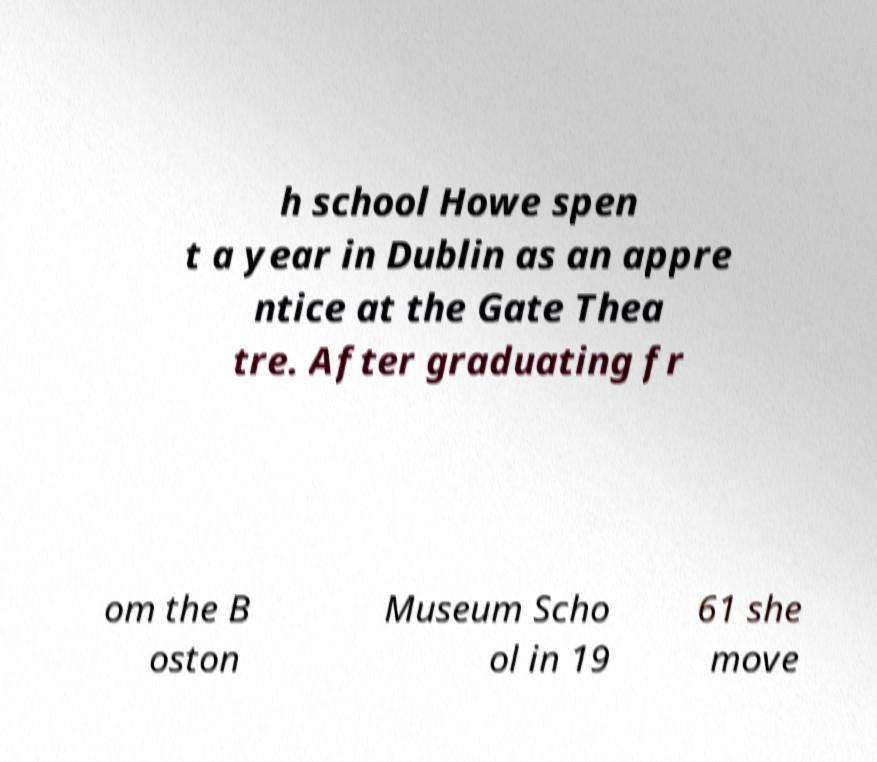For documentation purposes, I need the text within this image transcribed. Could you provide that? h school Howe spen t a year in Dublin as an appre ntice at the Gate Thea tre. After graduating fr om the B oston Museum Scho ol in 19 61 she move 